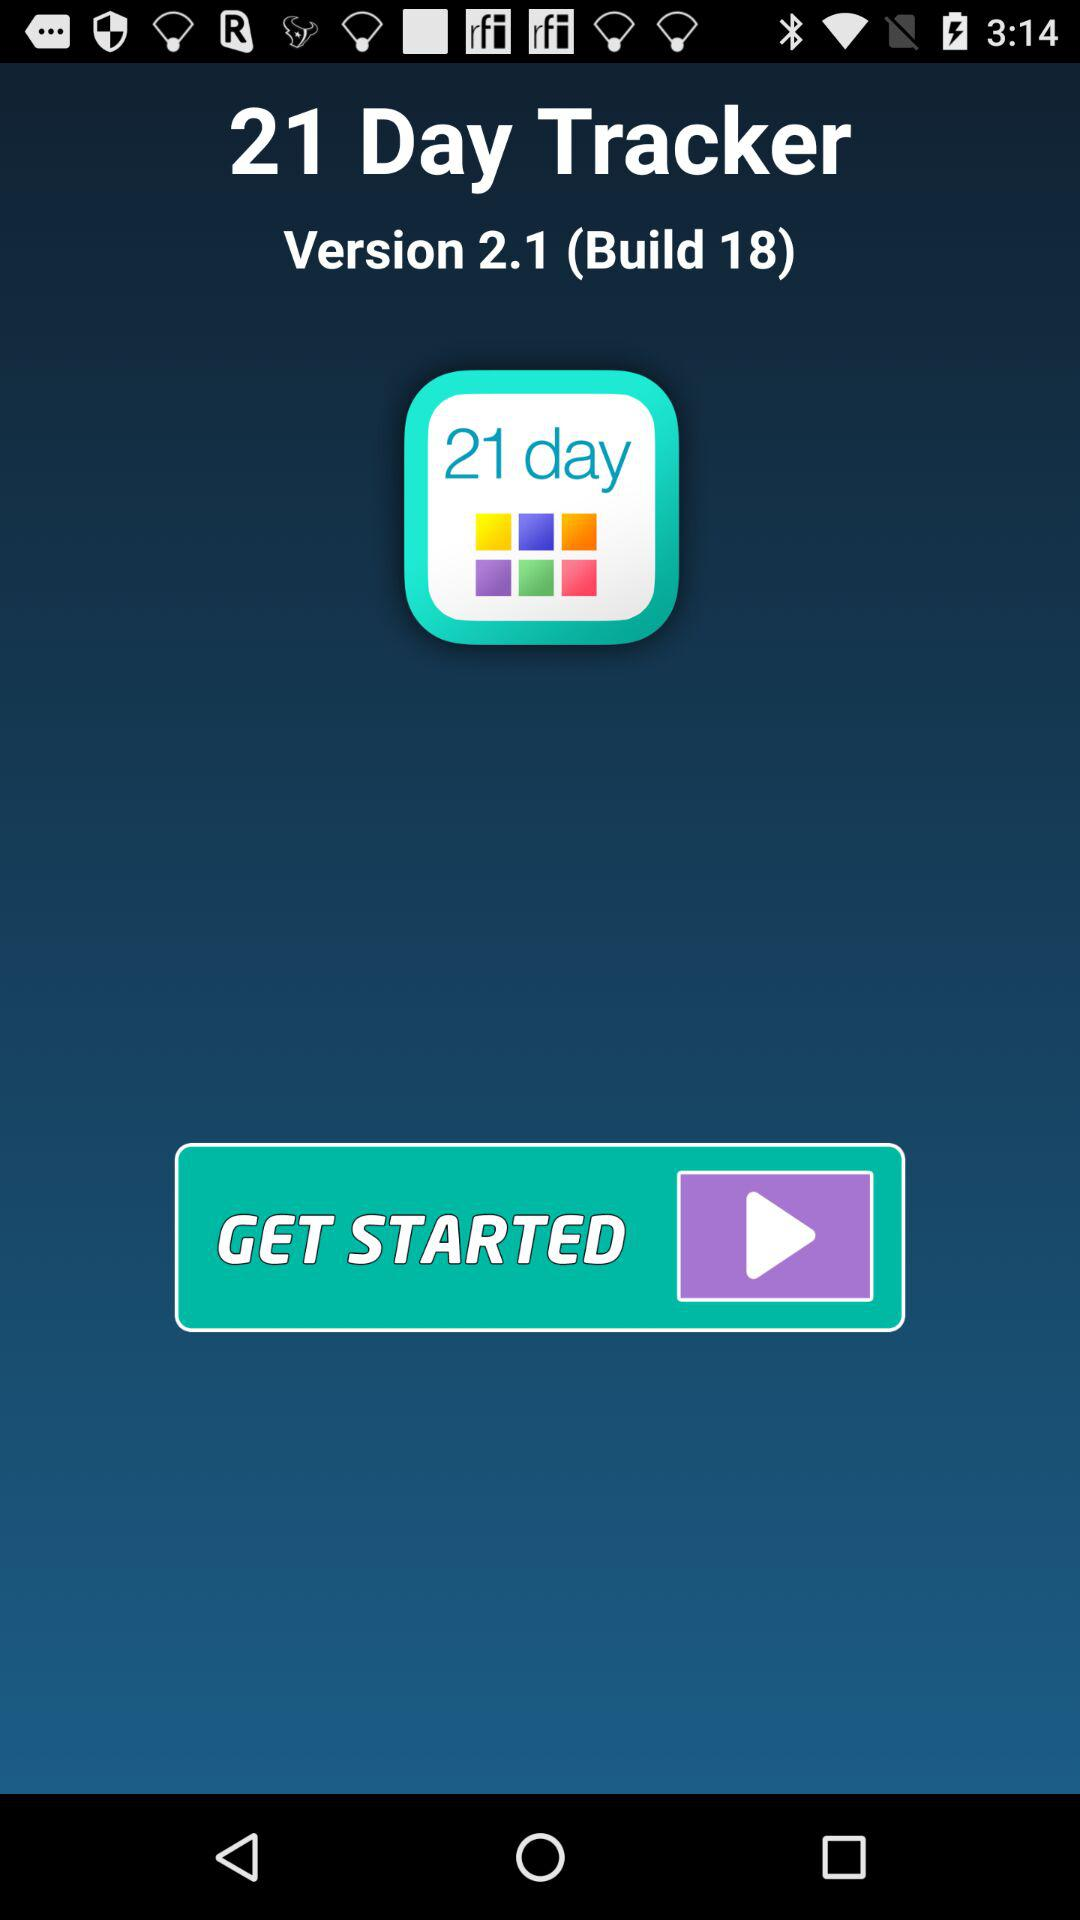What is the version of the application? The version of the application is 2.1 (Build 18). 